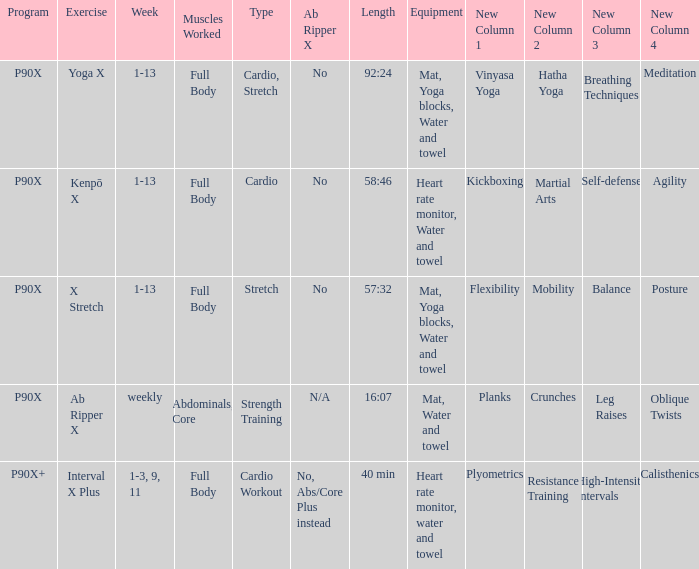Can you explain the ab ripper x when its length is set at 92:24? No. 